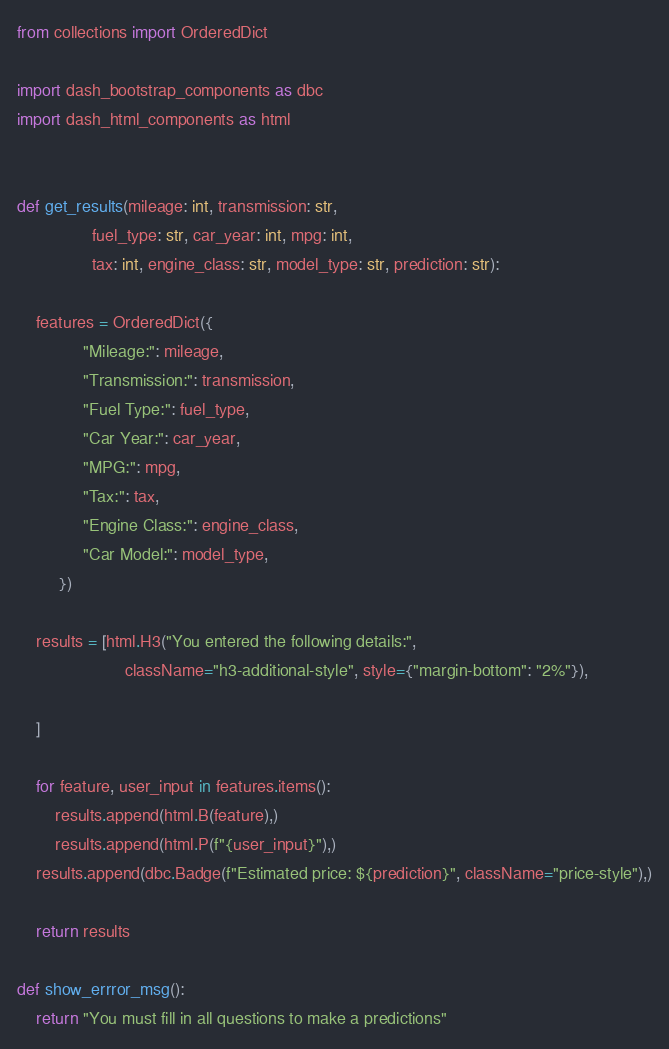<code> <loc_0><loc_0><loc_500><loc_500><_Python_>from collections import OrderedDict

import dash_bootstrap_components as dbc
import dash_html_components as html


def get_results(mileage: int, transmission: str, 
                fuel_type: str, car_year: int, mpg: int, 
                tax: int, engine_class: str, model_type: str, prediction: str):

    features = OrderedDict({
              "Mileage:": mileage, 
              "Transmission:": transmission, 
              "Fuel Type:": fuel_type,
              "Car Year:": car_year,
              "MPG:": mpg, 
              "Tax:": tax, 
              "Engine Class:": engine_class,
              "Car Model:": model_type,
         })
    
    results = [html.H3("You entered the following details:", 
                       className="h3-additional-style", style={"margin-bottom": "2%"}),
               
    ]

    for feature, user_input in features.items():
        results.append(html.B(feature),)
        results.append(html.P(f"{user_input}"),)
    results.append(dbc.Badge(f"Estimated price: ${prediction}", className="price-style"),)
    
    return results

def show_errror_msg():
    return "You must fill in all questions to make a predictions"</code> 